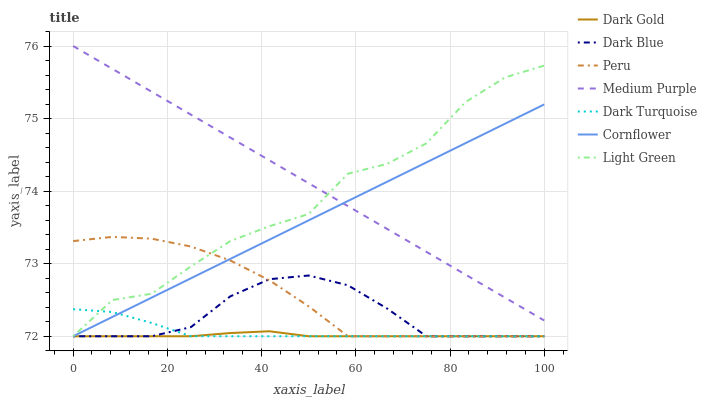Does Dark Gold have the minimum area under the curve?
Answer yes or no. Yes. Does Medium Purple have the maximum area under the curve?
Answer yes or no. Yes. Does Light Green have the minimum area under the curve?
Answer yes or no. No. Does Light Green have the maximum area under the curve?
Answer yes or no. No. Is Cornflower the smoothest?
Answer yes or no. Yes. Is Light Green the roughest?
Answer yes or no. Yes. Is Dark Gold the smoothest?
Answer yes or no. No. Is Dark Gold the roughest?
Answer yes or no. No. Does Medium Purple have the lowest value?
Answer yes or no. No. Does Light Green have the highest value?
Answer yes or no. No. Is Dark Turquoise less than Medium Purple?
Answer yes or no. Yes. Is Medium Purple greater than Dark Blue?
Answer yes or no. Yes. Does Dark Turquoise intersect Medium Purple?
Answer yes or no. No. 